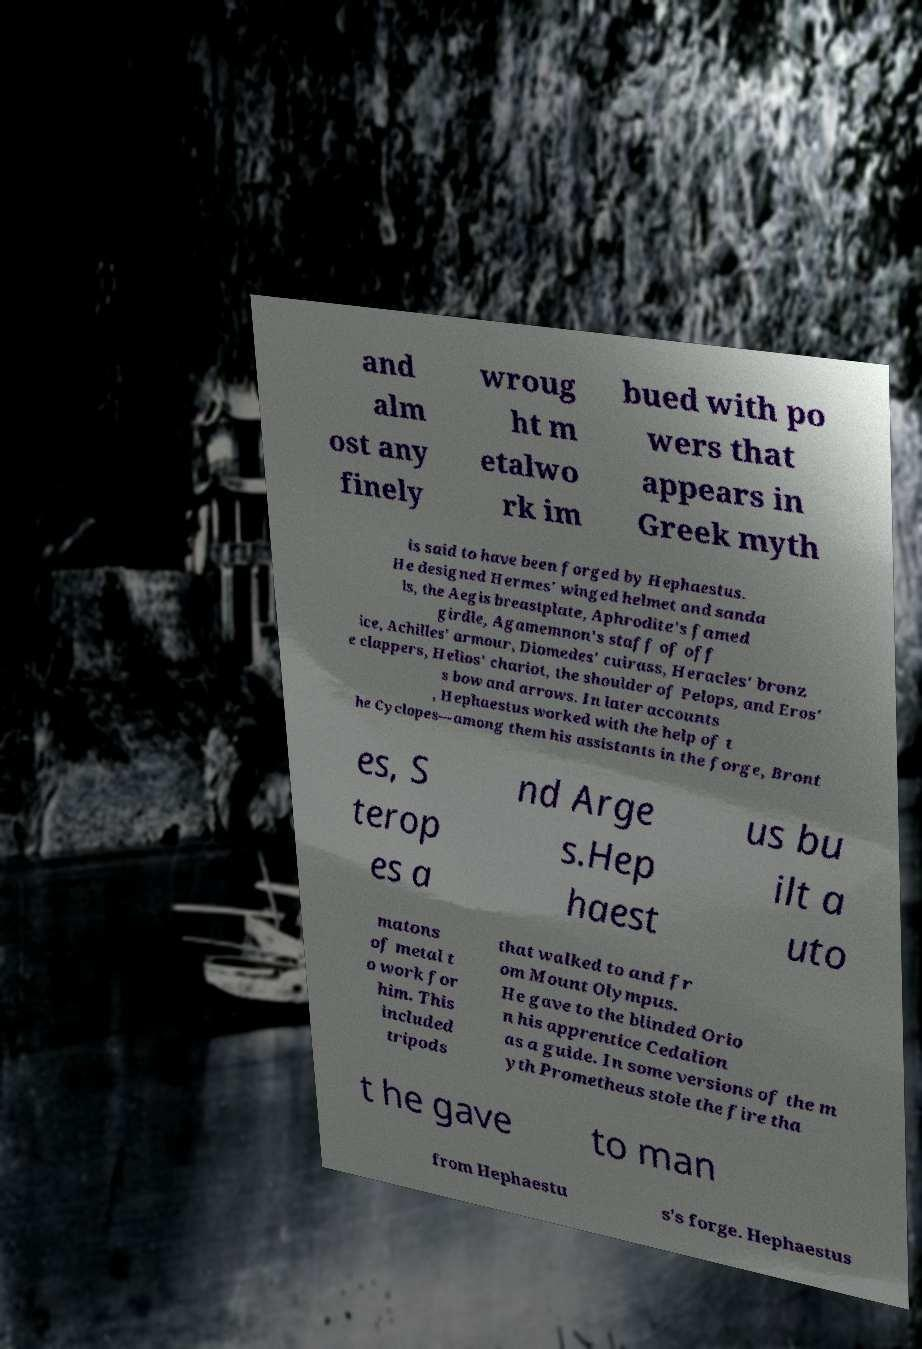Can you read and provide the text displayed in the image?This photo seems to have some interesting text. Can you extract and type it out for me? and alm ost any finely wroug ht m etalwo rk im bued with po wers that appears in Greek myth is said to have been forged by Hephaestus. He designed Hermes' winged helmet and sanda ls, the Aegis breastplate, Aphrodite's famed girdle, Agamemnon's staff of off ice, Achilles' armour, Diomedes' cuirass, Heracles' bronz e clappers, Helios' chariot, the shoulder of Pelops, and Eros' s bow and arrows. In later accounts , Hephaestus worked with the help of t he Cyclopes—among them his assistants in the forge, Bront es, S terop es a nd Arge s.Hep haest us bu ilt a uto matons of metal t o work for him. This included tripods that walked to and fr om Mount Olympus. He gave to the blinded Orio n his apprentice Cedalion as a guide. In some versions of the m yth Prometheus stole the fire tha t he gave to man from Hephaestu s's forge. Hephaestus 